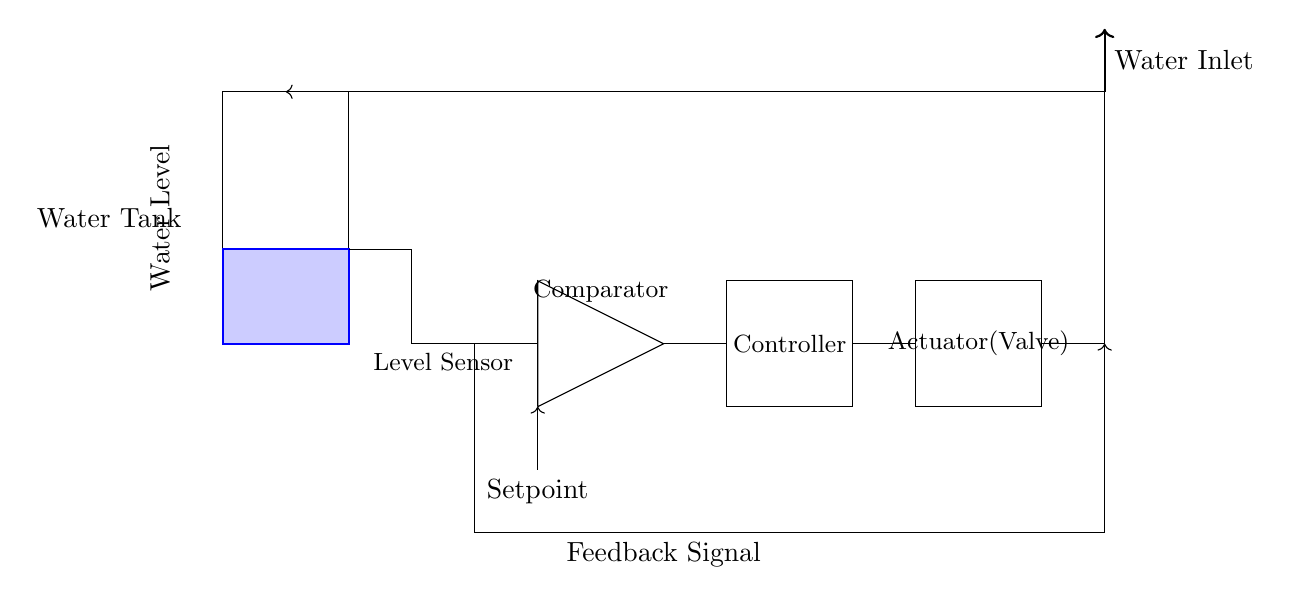What is the function of the comparator in the circuit? The comparator compares the feedback signal from the level sensor with the setpoint, determining whether to increase or decrease the actuation of the valve based on the water level.
Answer: Comparator What does the feedback loop represent in this control system? The feedback loop represents the continuous monitoring of the water level by sending the actual water level signal back to the comparator, allowing the system to make real-time adjustments.
Answer: Feedback loop What component regulates the flow of water into the tank? The actuator (valve) regulates the flow of water into the tank by opening or closing based on the controller's output signal.
Answer: Actuator (Valve) What is the role of the setpoint in the system? The setpoint defines the desired water level that the system aims to maintain within the tank, guiding the control actions of the comparator and controller.
Answer: Desired water level How does the water inlet affect the system's operation? The water inlet is the source of water for the tank, and its flow must be controlled correctly based on the output from the actuator to maintain the desired level as indicated by the level sensor.
Answer: Source of water What is the output of the controller determined by? The output of the controller is determined by the comparison result from the comparator, which indicates whether the current water level is above or below the setpoint.
Answer: Comparison result 